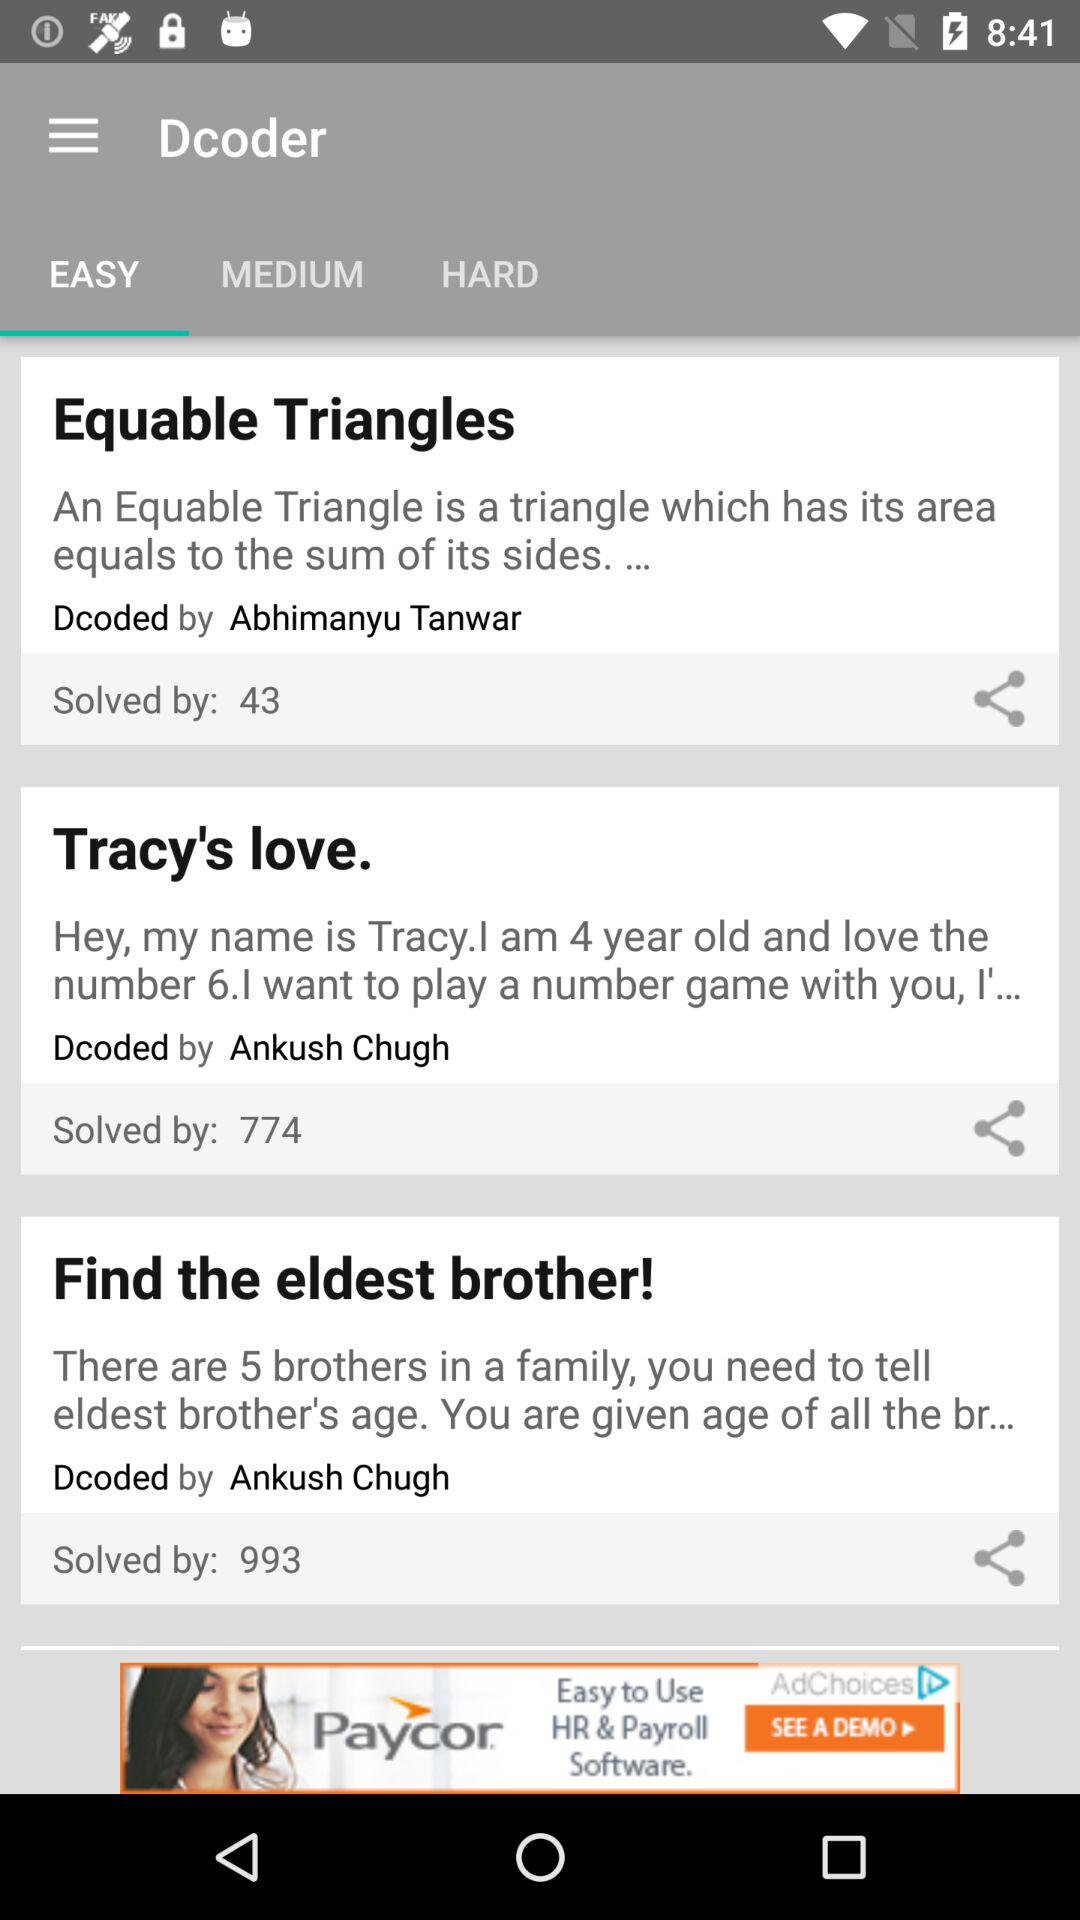Who decodes "Tracy's love"? The "Tracy's love" decoded by Ankush Chugh. 